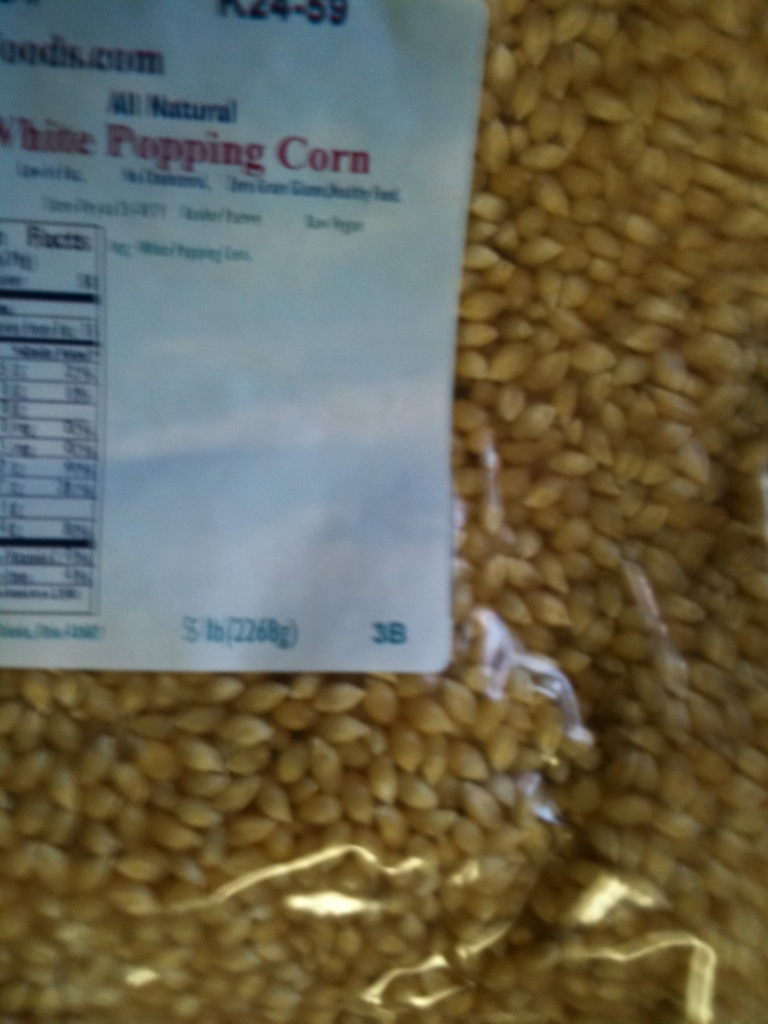Can you tell me the nutritional information of this popping corn? The nutritional information for this popping corn typically includes serving size, calories per serving, and amounts of fat, cholesterol, sodium, carbohydrates, dietary fiber, sugar, and protein. For a specific breakdown, it’s best to refer to the label on the package. Popping corn is usually low in fat and calories and high in fiber, making it a great healthy snack option when prepared without excessive butter or oil. 